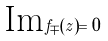Convert formula to latex. <formula><loc_0><loc_0><loc_500><loc_500>\text {Im} f _ { \mp } ( z ) = 0</formula> 